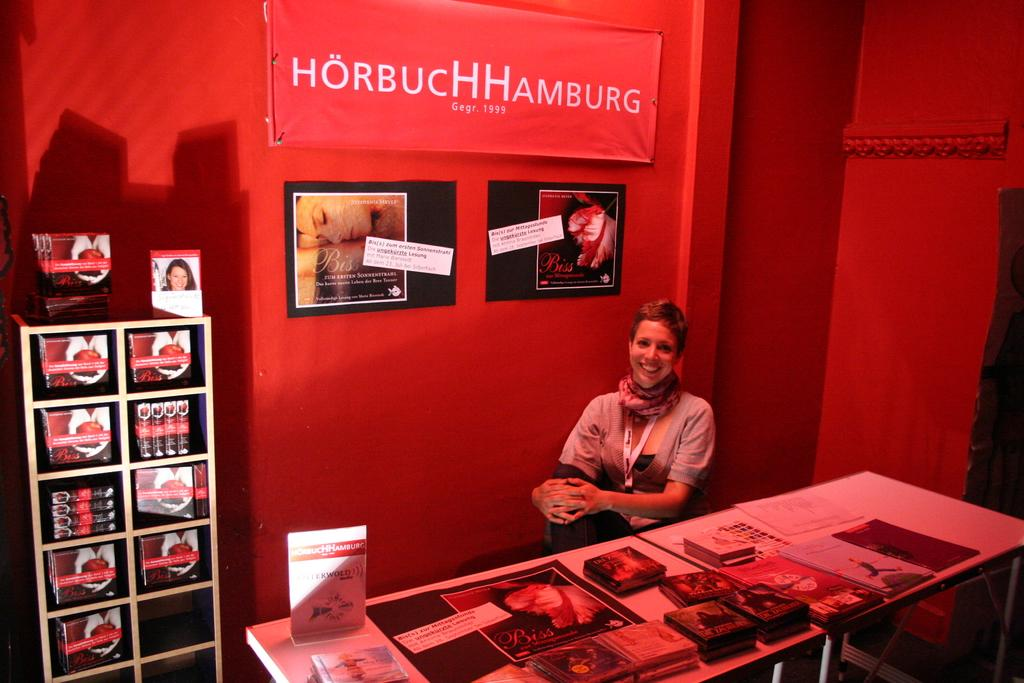<image>
Present a compact description of the photo's key features. In a red room a woman sits by HorbucHHamburg products. 